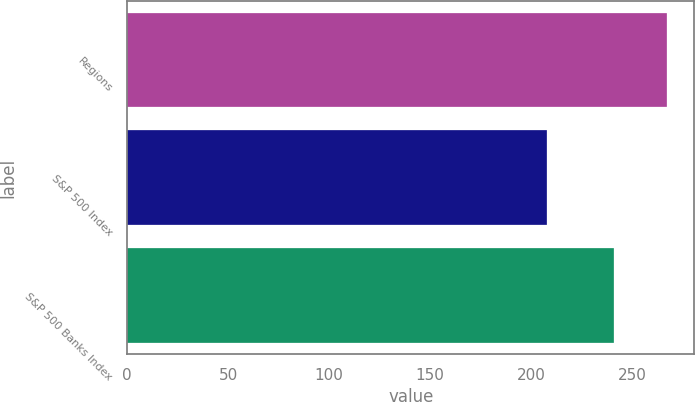Convert chart. <chart><loc_0><loc_0><loc_500><loc_500><bar_chart><fcel>Regions<fcel>S&P 500 Index<fcel>S&P 500 Banks Index<nl><fcel>267.4<fcel>208.05<fcel>240.87<nl></chart> 